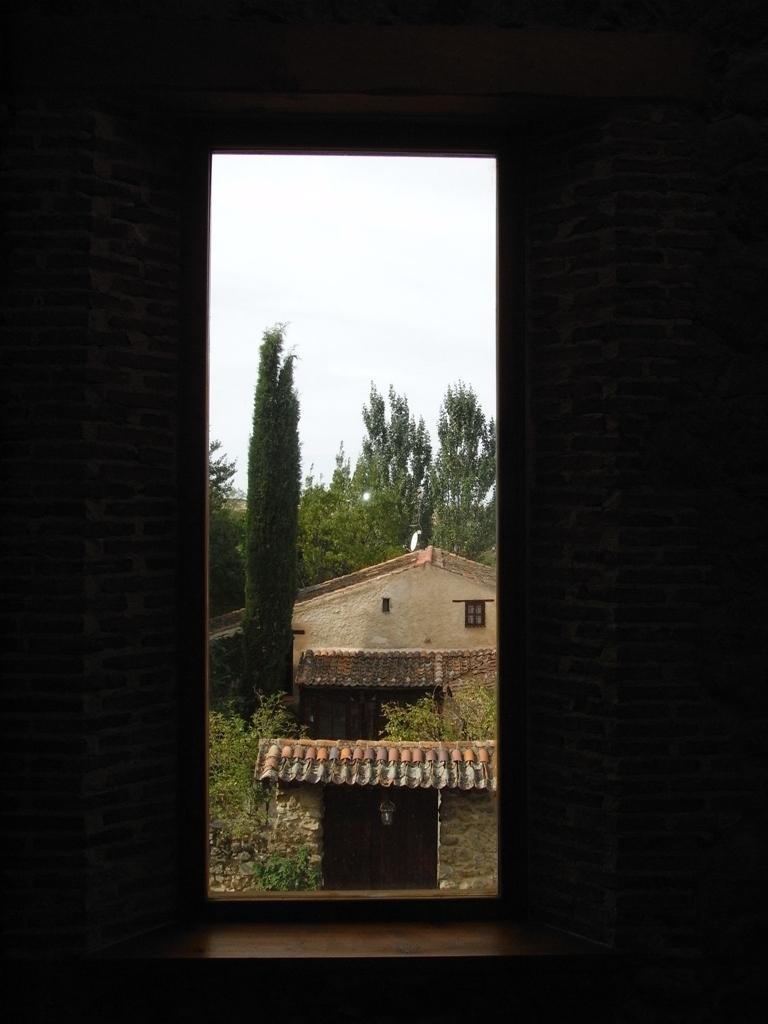What is located on the right side of the image? There is a wall on the right side of the image. What is located on the left side of the image? There is a wall on the left side of the image. What can be seen in the background of the image? There is a house and trees in the background of the image. What is visible at the top of the image? The sky is visible at the top of the image. What type of list can be seen on the wall in the image? There is no list present on the walls in the image; only walls, a house, trees, and the sky are visible. How many weeks are depicted in the image? There is no reference to weeks or time in the image, so it is not possible to determine how many weeks are depicted. 